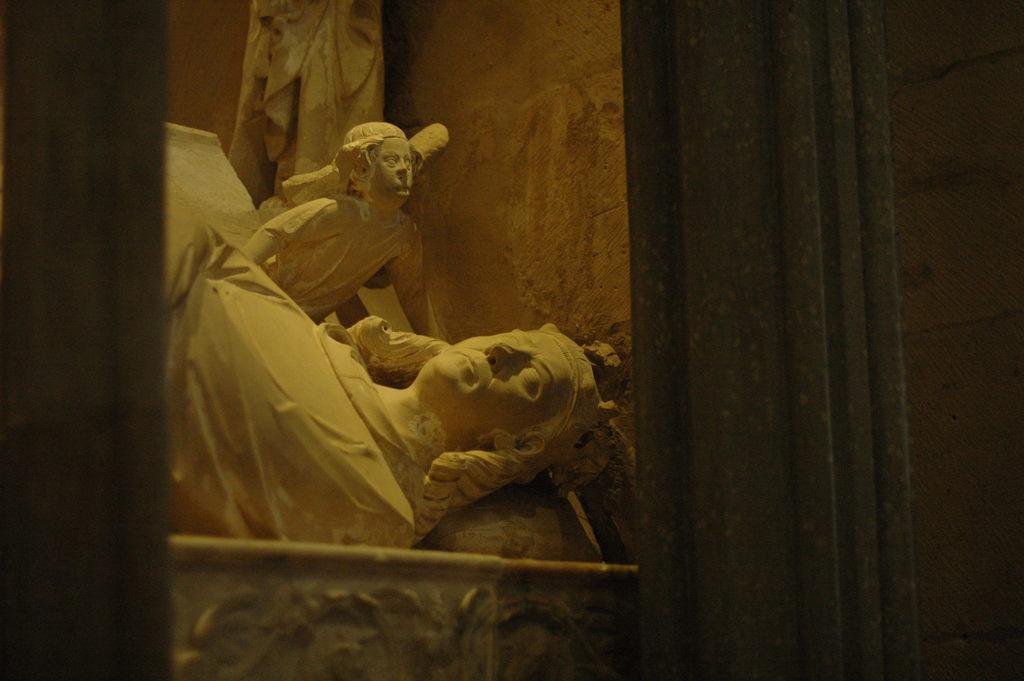How would you summarize this image in a sentence or two? In this picture we can see statues in the middle, on the right side there is a curtain, we can see a wall in the background. 